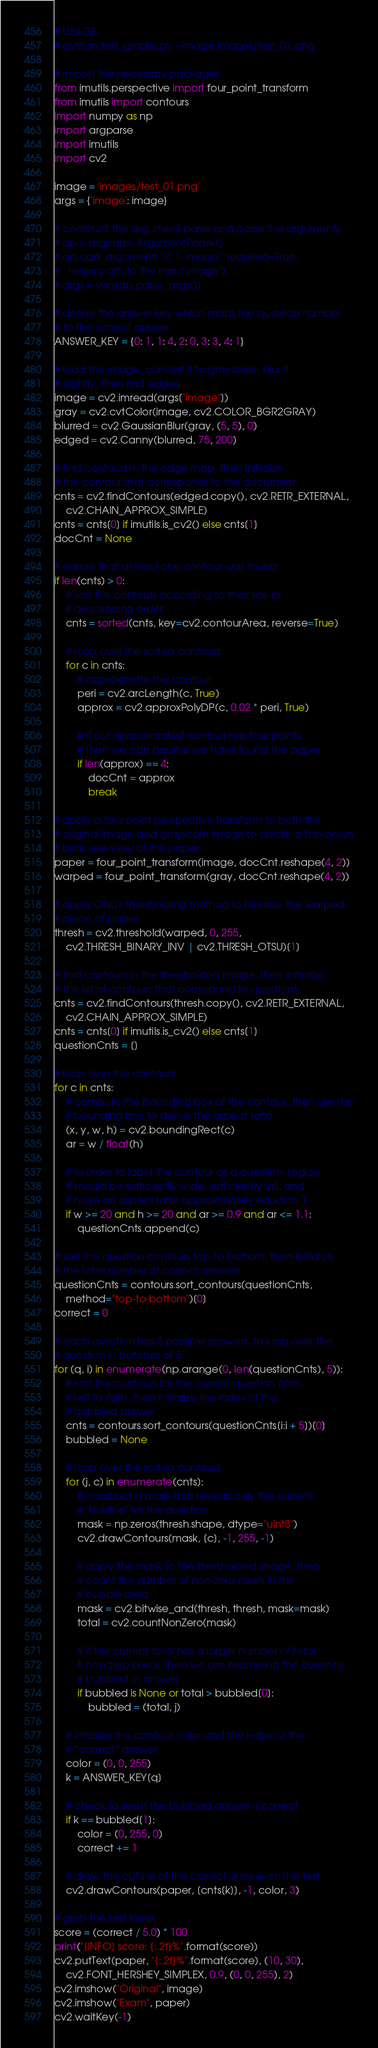<code> <loc_0><loc_0><loc_500><loc_500><_Python_># USAGE
# python test_grader.py --image images/test_01.png

# import the necessary packages
from imutils.perspective import four_point_transform
from imutils import contours
import numpy as np
import argparse
import imutils
import cv2

image = 'images/test_01.png'
args = {'image': image}

# construct the argument parse and parse the arguments
# ap = argparse.ArgumentParser()
# ap.add_argument("-i", "--image", required=True,
# 	help="path to the input image")
# args = vars(ap.parse_args())

# define the answer key which maps the question number
# to the correct answer
ANSWER_KEY = {0: 1, 1: 4, 2: 0, 3: 3, 4: 1}

# load the image, convert it to grayscale, blur it
# slightly, then find edges
image = cv2.imread(args["image"])
gray = cv2.cvtColor(image, cv2.COLOR_BGR2GRAY)
blurred = cv2.GaussianBlur(gray, (5, 5), 0)
edged = cv2.Canny(blurred, 75, 200)	

# find contours in the edge map, then initialize
# the contour that corresponds to the document
cnts = cv2.findContours(edged.copy(), cv2.RETR_EXTERNAL,
	cv2.CHAIN_APPROX_SIMPLE)
cnts = cnts[0] if imutils.is_cv2() else cnts[1]
docCnt = None

# ensure that at least one contour was found
if len(cnts) > 0:
	# sort the contours according to their size in
	# descending order
	cnts = sorted(cnts, key=cv2.contourArea, reverse=True)

	# loop over the sorted contours
	for c in cnts:
		# approximate the contour
		peri = cv2.arcLength(c, True)
		approx = cv2.approxPolyDP(c, 0.02 * peri, True)

		# if our approximated contour has four points,
		# then we can assume we have found the paper
		if len(approx) == 4:
			docCnt = approx
			break

# apply a four point perspective transform to both the
# original image and grayscale image to obtain a top-down
# birds eye view of the paper
paper = four_point_transform(image, docCnt.reshape(4, 2))
warped = four_point_transform(gray, docCnt.reshape(4, 2))

# apply Otsu's thresholding method to binarize the warped
# piece of paper
thresh = cv2.threshold(warped, 0, 255,
	cv2.THRESH_BINARY_INV | cv2.THRESH_OTSU)[1]

# find contours in the thresholded image, then initialize
# the list of contours that correspond to questions
cnts = cv2.findContours(thresh.copy(), cv2.RETR_EXTERNAL,
	cv2.CHAIN_APPROX_SIMPLE)
cnts = cnts[0] if imutils.is_cv2() else cnts[1]
questionCnts = []

# loop over the contours
for c in cnts:
	# compute the bounding box of the contour, then use the
	# bounding box to derive the aspect ratio
	(x, y, w, h) = cv2.boundingRect(c)
	ar = w / float(h)

	# in order to label the contour as a question, region
	# should be sufficiently wide, sufficiently tall, and
	# have an aspect ratio approximately equal to 1
	if w >= 20 and h >= 20 and ar >= 0.9 and ar <= 1.1:
		questionCnts.append(c)

# sort the question contours top-to-bottom, then initialize
# the total number of correct answers
questionCnts = contours.sort_contours(questionCnts,
	method="top-to-bottom")[0]
correct = 0

# each question has 5 possible answers, to loop over the
# question in batches of 5
for (q, i) in enumerate(np.arange(0, len(questionCnts), 5)):
	# sort the contours for the current question from
	# left to right, then initialize the index of the
	# bubbled answer
	cnts = contours.sort_contours(questionCnts[i:i + 5])[0]
	bubbled = None

	# loop over the sorted contours
	for (j, c) in enumerate(cnts):
		# construct a mask that reveals only the current
		# "bubble" for the question
		mask = np.zeros(thresh.shape, dtype="uint8")
		cv2.drawContours(mask, [c], -1, 255, -1)

		# apply the mask to the thresholded image, then
		# count the number of non-zero pixels in the
		# bubble area
		mask = cv2.bitwise_and(thresh, thresh, mask=mask)
		total = cv2.countNonZero(mask)

		# if the current total has a larger number of total
		# non-zero pixels, then we are examining the currently
		# bubbled-in answer
		if bubbled is None or total > bubbled[0]:
			bubbled = (total, j)

	# initialize the contour color and the index of the
	# *correct* answer
	color = (0, 0, 255)
	k = ANSWER_KEY[q]

	# check to see if the bubbled answer is correct
	if k == bubbled[1]:
		color = (0, 255, 0)
		correct += 1

	# draw the outline of the correct answer on the test
	cv2.drawContours(paper, [cnts[k]], -1, color, 3)

# grab the test taker
score = (correct / 5.0) * 100
print("[INFO] score: {:.2f}%".format(score))
cv2.putText(paper, "{:.2f}%".format(score), (10, 30),
	cv2.FONT_HERSHEY_SIMPLEX, 0.9, (0, 0, 255), 2)
cv2.imshow("Original", image)
cv2.imshow("Exam", paper)
cv2.waitKey(-1)</code> 